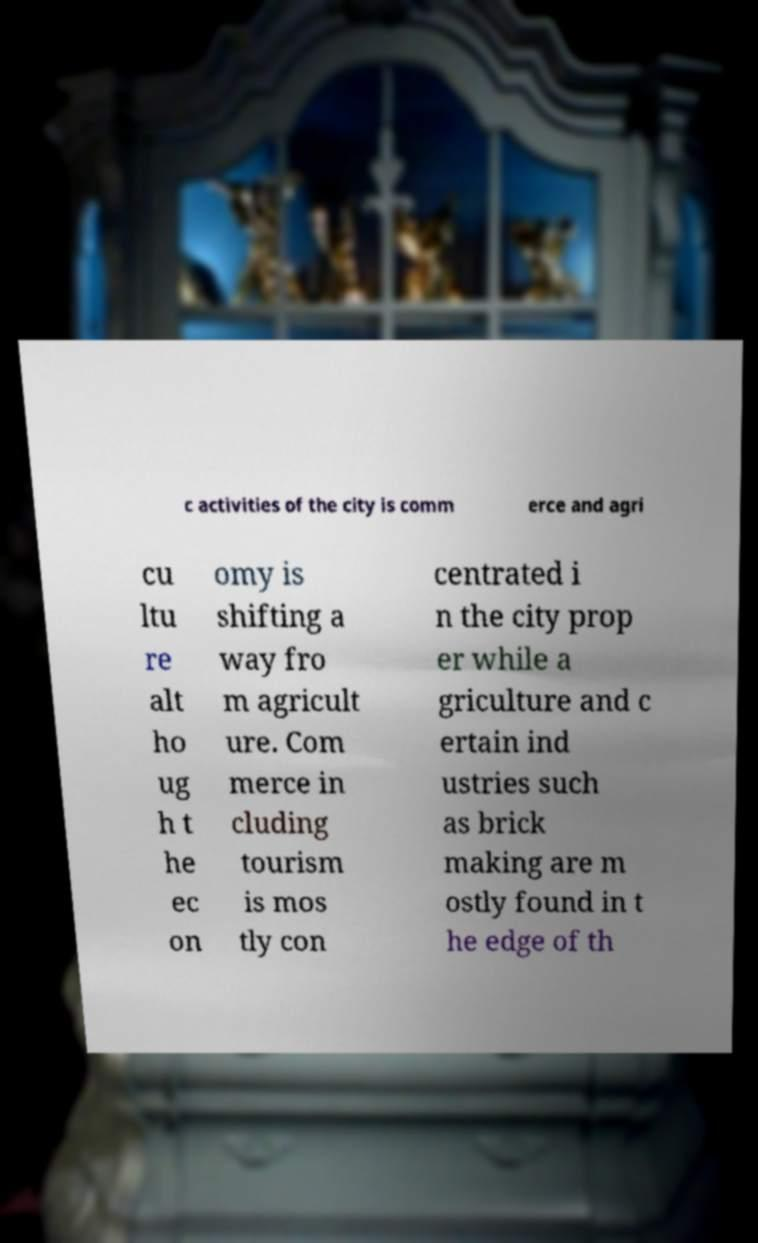Can you accurately transcribe the text from the provided image for me? c activities of the city is comm erce and agri cu ltu re alt ho ug h t he ec on omy is shifting a way fro m agricult ure. Com merce in cluding tourism is mos tly con centrated i n the city prop er while a griculture and c ertain ind ustries such as brick making are m ostly found in t he edge of th 